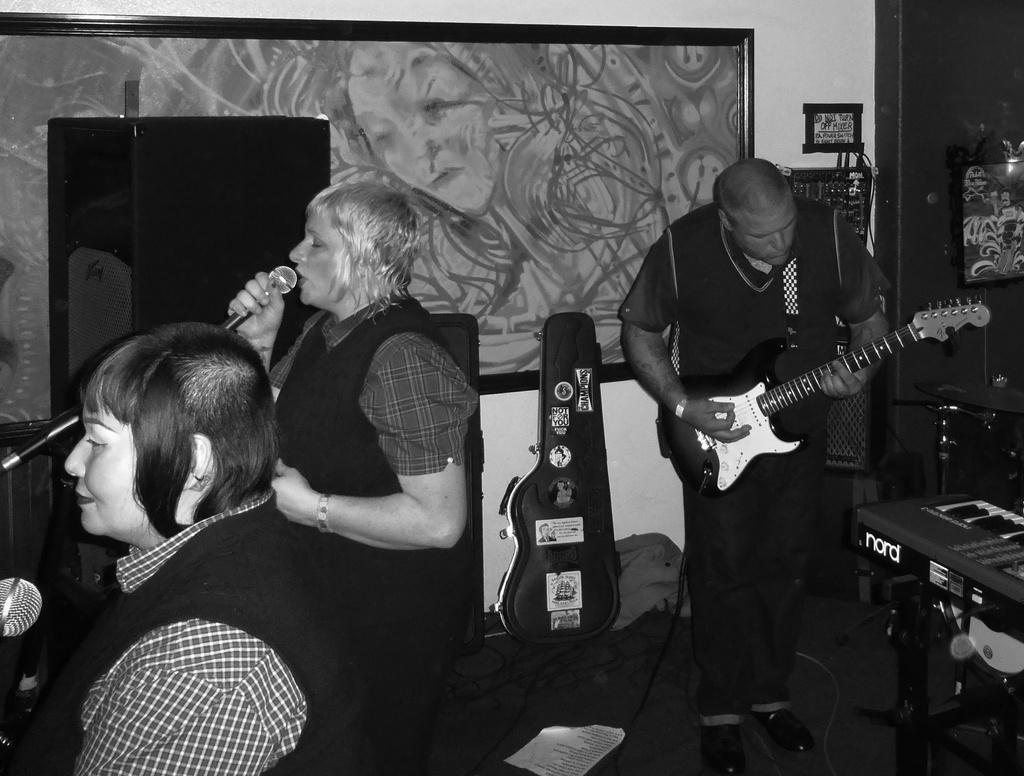In one or two sentences, can you explain what this image depicts? This picture shows two women singing with the help of a microphone and we see a man playing guitar on their back 